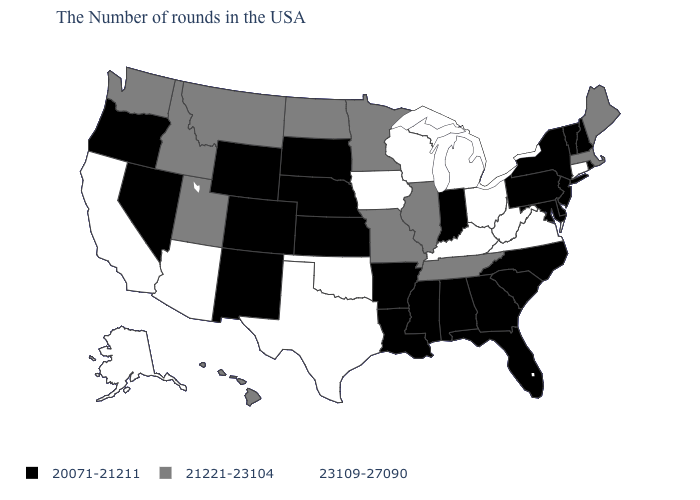What is the value of Montana?
Give a very brief answer. 21221-23104. What is the value of South Carolina?
Write a very short answer. 20071-21211. Is the legend a continuous bar?
Answer briefly. No. What is the value of Massachusetts?
Give a very brief answer. 21221-23104. Which states have the lowest value in the USA?
Short answer required. Rhode Island, New Hampshire, Vermont, New York, New Jersey, Delaware, Maryland, Pennsylvania, North Carolina, South Carolina, Florida, Georgia, Indiana, Alabama, Mississippi, Louisiana, Arkansas, Kansas, Nebraska, South Dakota, Wyoming, Colorado, New Mexico, Nevada, Oregon. What is the value of Montana?
Write a very short answer. 21221-23104. Does Nevada have a lower value than Kansas?
Write a very short answer. No. Does the map have missing data?
Quick response, please. No. Name the states that have a value in the range 20071-21211?
Short answer required. Rhode Island, New Hampshire, Vermont, New York, New Jersey, Delaware, Maryland, Pennsylvania, North Carolina, South Carolina, Florida, Georgia, Indiana, Alabama, Mississippi, Louisiana, Arkansas, Kansas, Nebraska, South Dakota, Wyoming, Colorado, New Mexico, Nevada, Oregon. Among the states that border Missouri , which have the highest value?
Answer briefly. Kentucky, Iowa, Oklahoma. Is the legend a continuous bar?
Answer briefly. No. What is the value of Wisconsin?
Answer briefly. 23109-27090. Is the legend a continuous bar?
Concise answer only. No. What is the value of Oklahoma?
Give a very brief answer. 23109-27090. Does the map have missing data?
Give a very brief answer. No. 